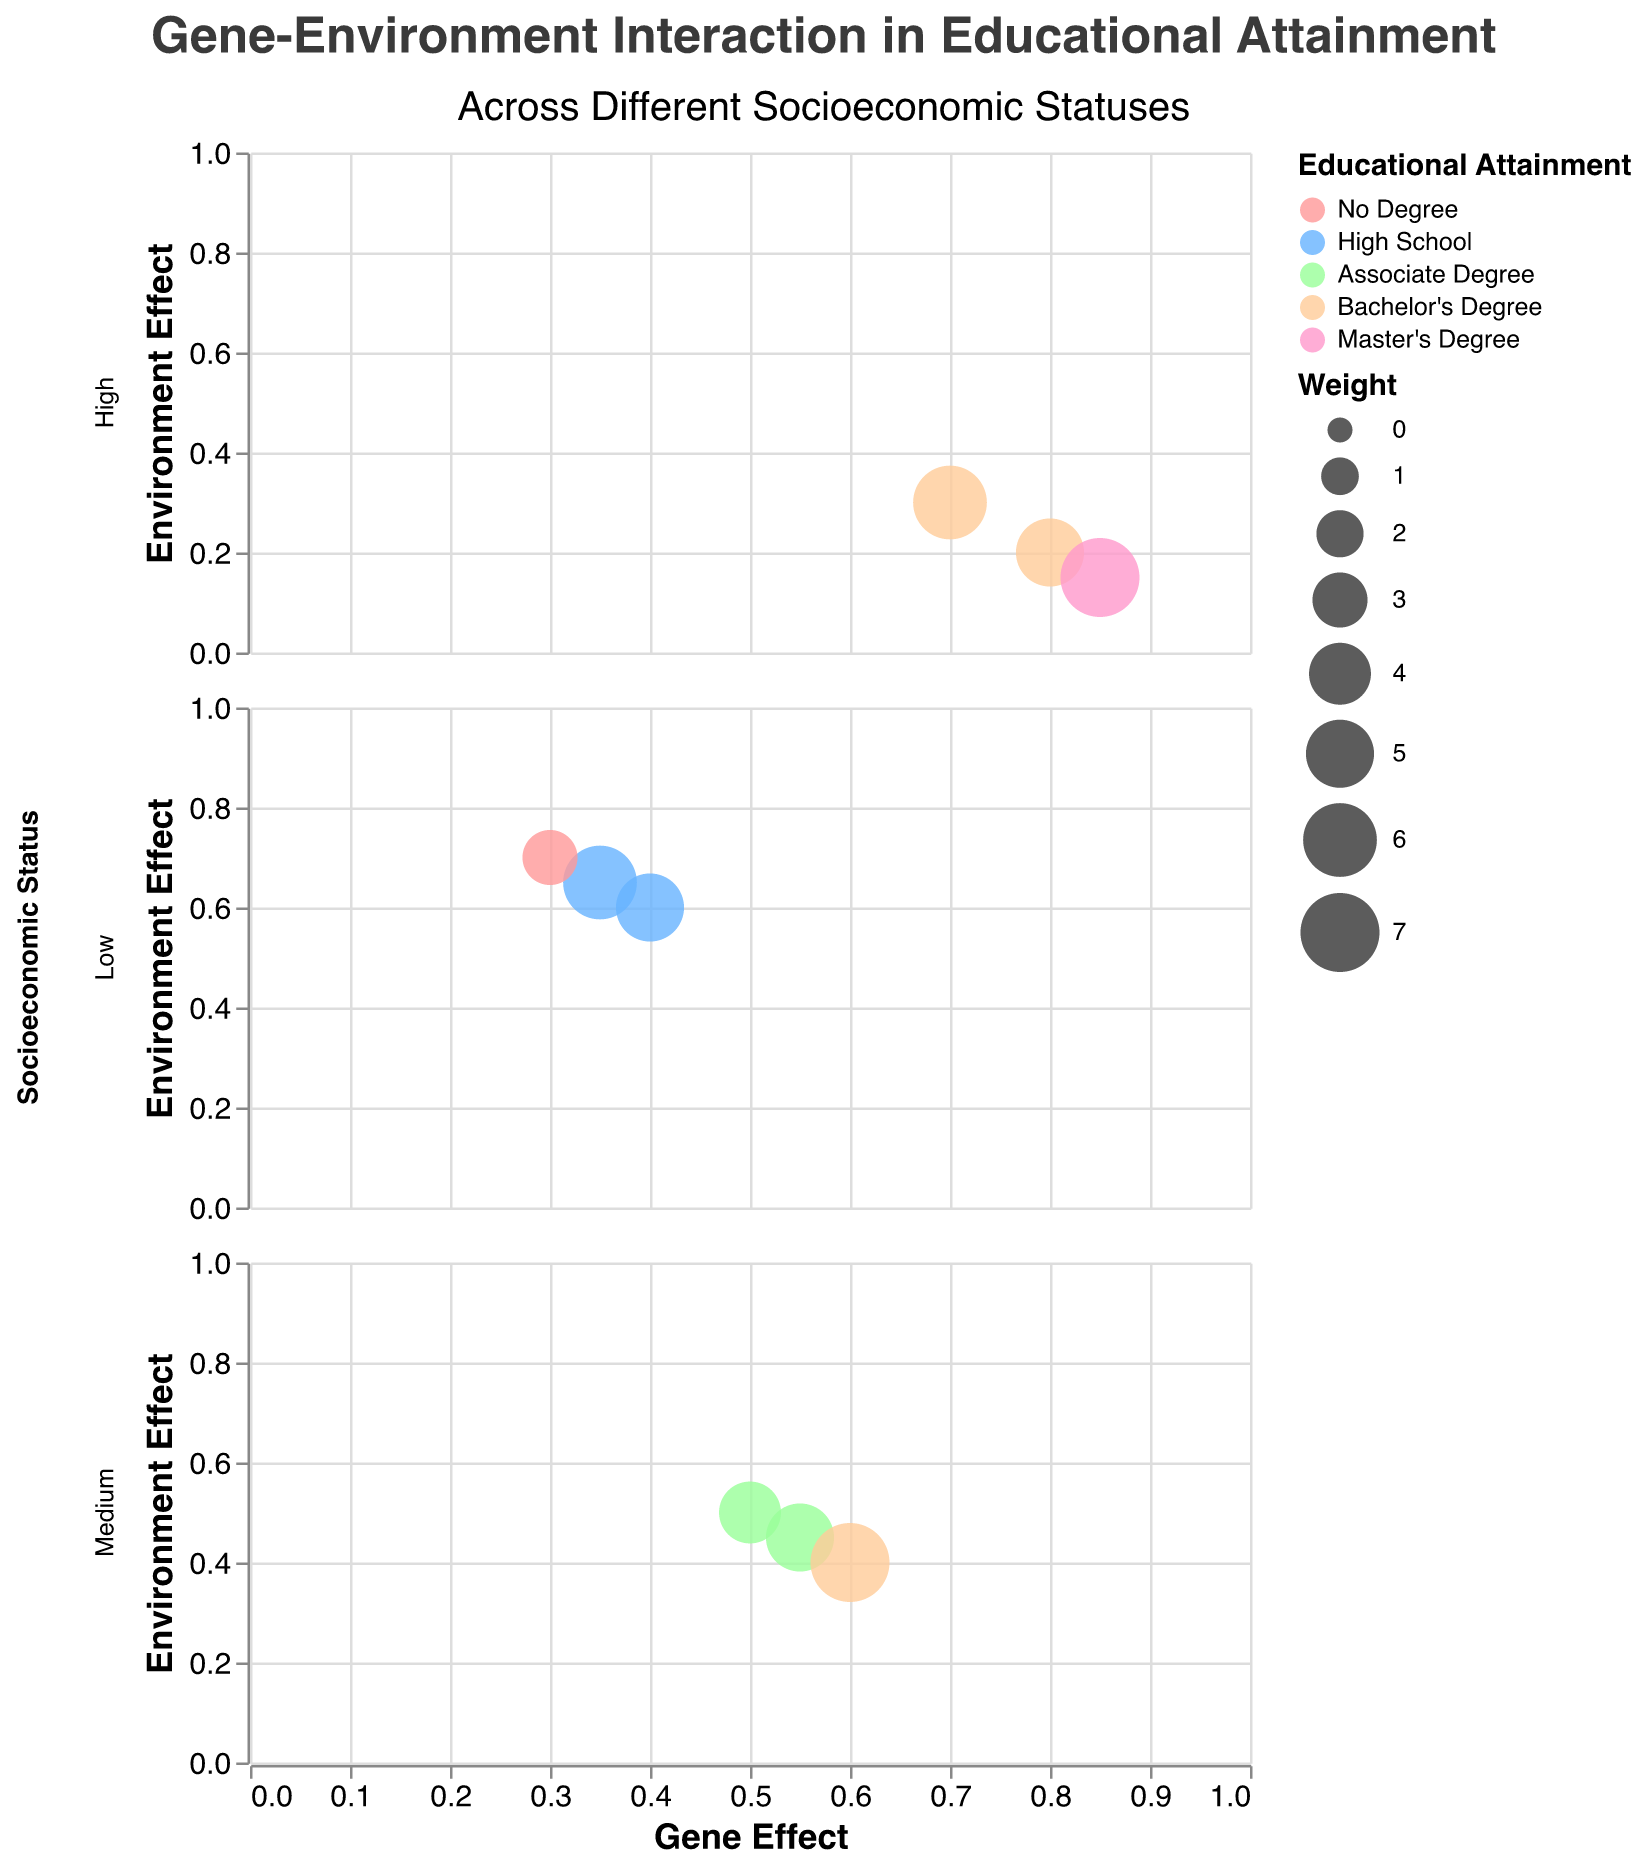What is the title of the figure? The title is located at the top of the figure and provides a quick summary of what the chart is depicting.
Answer: Gene-Environment Interaction in Educational Attainment What are the labels of the axes? The x-axis label is near the bottom of the figure, and the y-axis label is on the left side.
Answer: The x-axis is labeled "Gene Effect" and the y-axis is labeled "Environment Effect" How many data points represent high socioeconomic status (SES)? By counting the number of points in the "High" socioeconomic status section, we tally up the data points.
Answer: 3 Which twin pair has the highest gene effect? By observing the data points, the twin pair with the highest x-value (Gene Effect) is identified.
Answer: Twin pair 9 What's the average gene effect for medium socioeconomic status? Sum the gene effects for medium SES (0.50, 0.55, 0.60) and divide by the number of data points (3).
Answer: (0.50 + 0.55 + 0.60) / 3 = 0.55 Which educational attainment level color appears most frequently? By counting the number of data points for each color, the most frequent color is found.
Answer: Bachelor's Degree (color: orange) Compare the gene effect and environment effect for twin pairs in low socioeconomic status. Review the low SES section and compare the gene and environment effects of each twin pair.
Answer: Gene effects are generally lower than environment effects for all pairs in low SES Which socioeconomic status group shows the highest overall educational attainment? Focus on the one's with higher educational attainment such as bachelor's and master's degree and the socioeconomic group that has these educational attainments.
Answer: High SES Are there any data points where the gene effect equals the environment effect? Evaluate if any points lie on the line where x-value equals y-value.
Answer: Yes, twin pair 4 in medium SES What is the weight of the data point with a Gene Effect of 0.60 in medium SES? Identify the data point with a gene effect of 0.60 in the medium SES section and look up its weight.
Answer: 7 